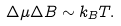<formula> <loc_0><loc_0><loc_500><loc_500>\Delta \mu \Delta B \sim k _ { B } T .</formula> 